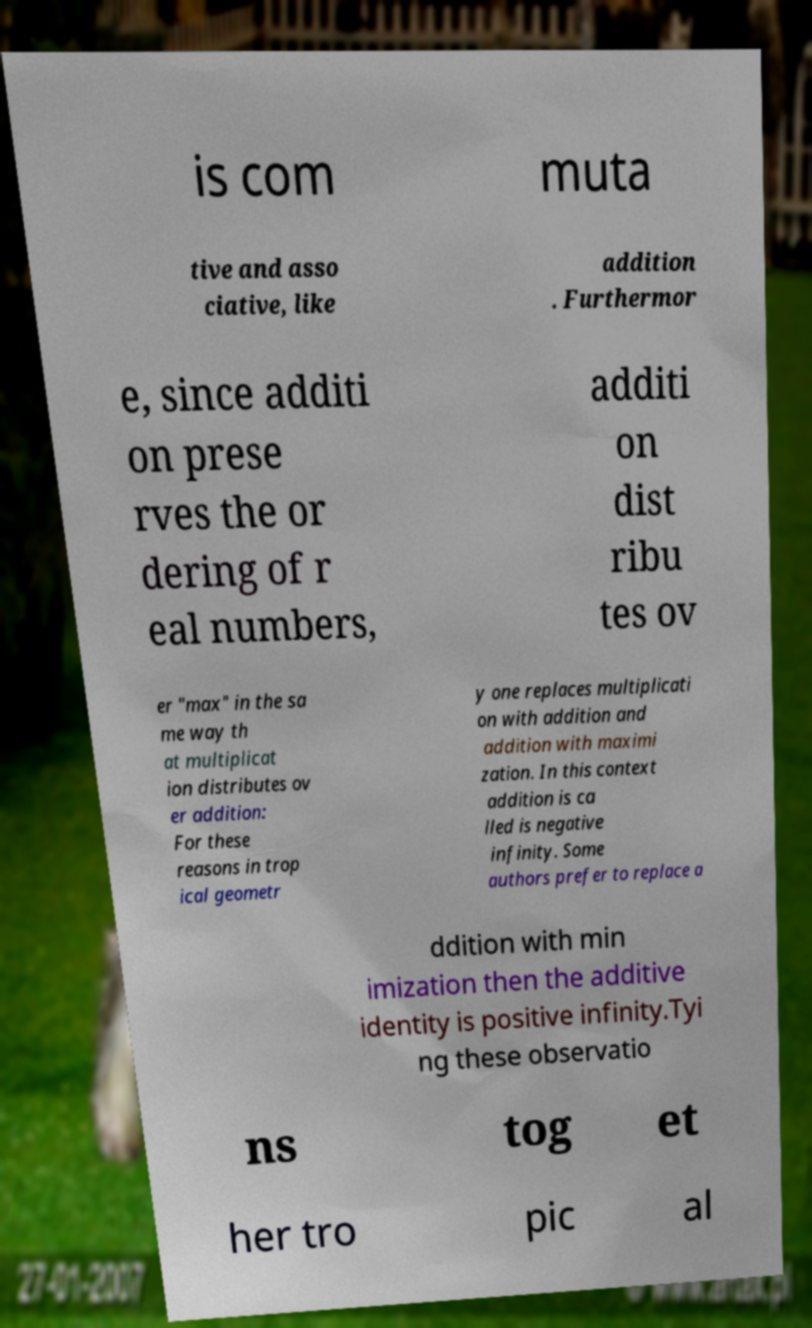What messages or text are displayed in this image? I need them in a readable, typed format. is com muta tive and asso ciative, like addition . Furthermor e, since additi on prese rves the or dering of r eal numbers, additi on dist ribu tes ov er "max" in the sa me way th at multiplicat ion distributes ov er addition: For these reasons in trop ical geometr y one replaces multiplicati on with addition and addition with maximi zation. In this context addition is ca lled is negative infinity. Some authors prefer to replace a ddition with min imization then the additive identity is positive infinity.Tyi ng these observatio ns tog et her tro pic al 